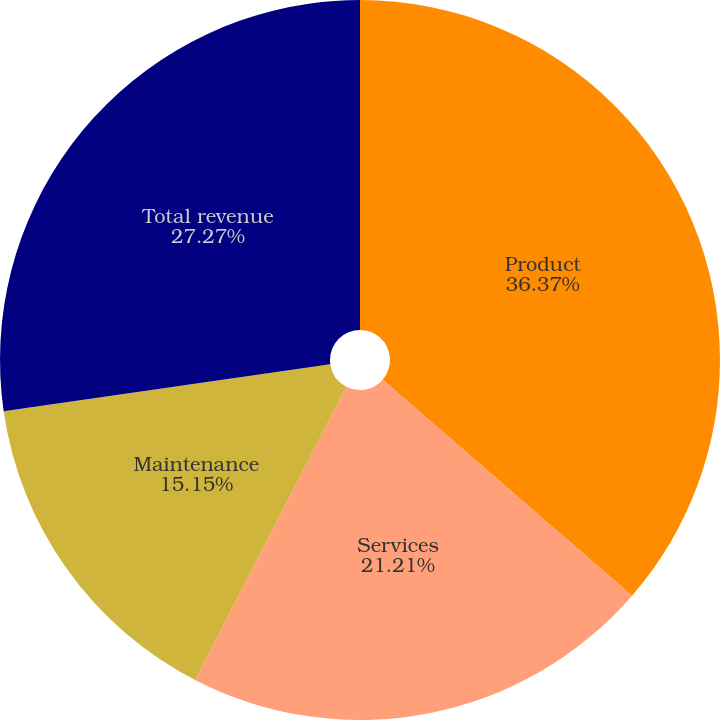Convert chart to OTSL. <chart><loc_0><loc_0><loc_500><loc_500><pie_chart><fcel>Product<fcel>Services<fcel>Maintenance<fcel>Total revenue<nl><fcel>36.36%<fcel>21.21%<fcel>15.15%<fcel>27.27%<nl></chart> 